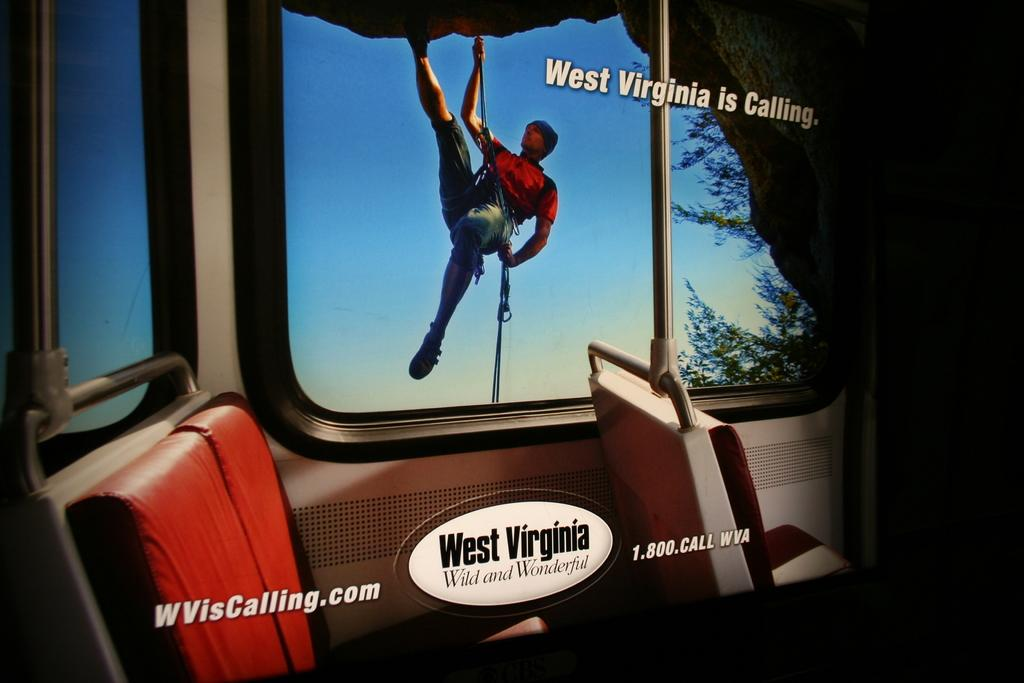What objects are present in the image for sitting? There are seats in the image. What activity is the person in the image engaged in? The person is climbing a mountain in the image. How is the person assisted while climbing the mountain? The person is using a rope for assistance while climbing. What is the rate of wax production in the image? There is no mention of wax or its production in the image, so it is not possible to determine the rate of wax production. 